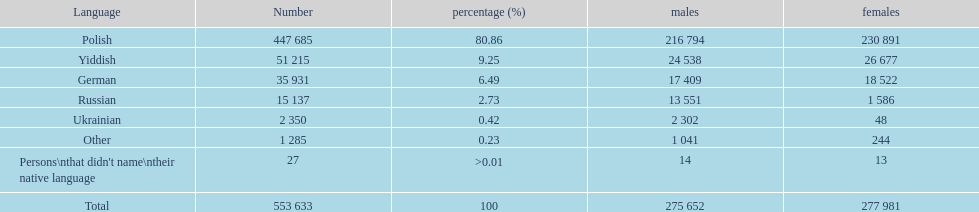How many individuals didn't identify their mother tongue? 27. 